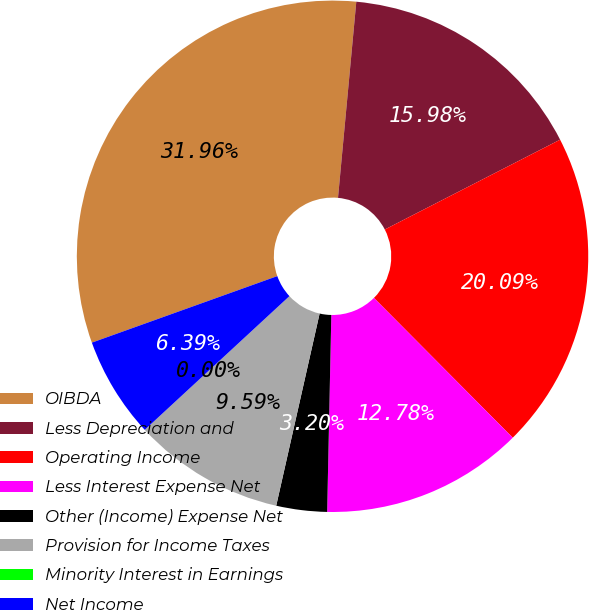Convert chart to OTSL. <chart><loc_0><loc_0><loc_500><loc_500><pie_chart><fcel>OIBDA<fcel>Less Depreciation and<fcel>Operating Income<fcel>Less Interest Expense Net<fcel>Other (Income) Expense Net<fcel>Provision for Income Taxes<fcel>Minority Interest in Earnings<fcel>Net Income<nl><fcel>31.96%<fcel>15.98%<fcel>20.09%<fcel>12.78%<fcel>3.2%<fcel>9.59%<fcel>0.0%<fcel>6.39%<nl></chart> 